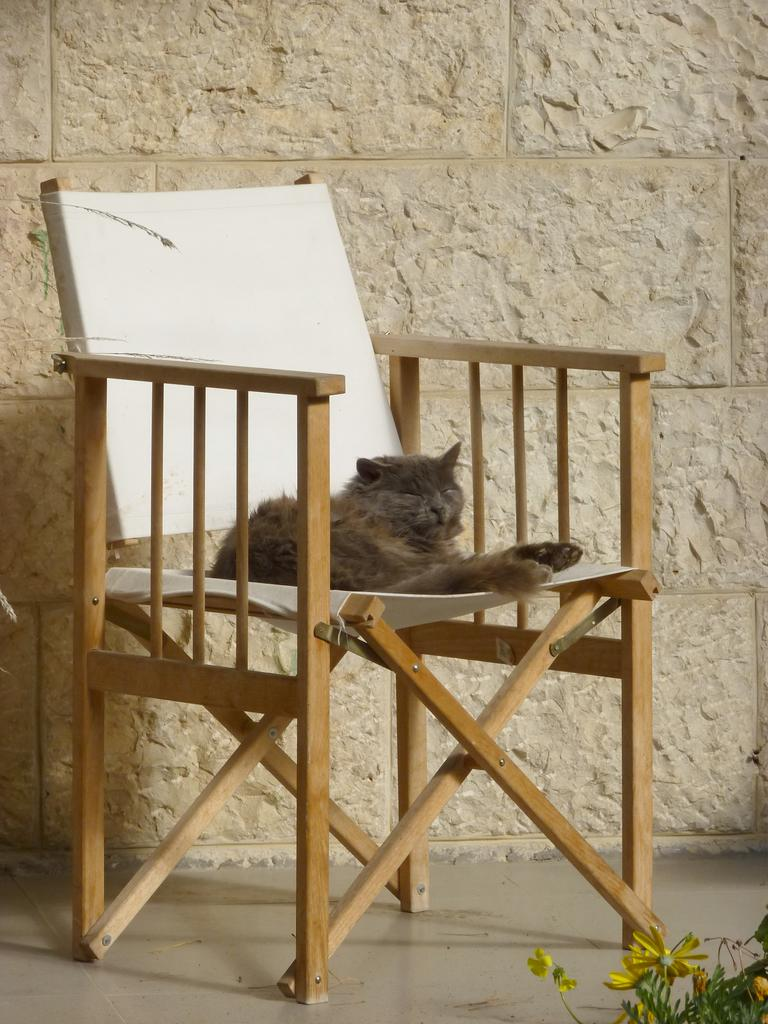What animal can be seen in the image? There is a cat in the image. Where is the cat sitting? The cat is sitting in a white color chair. What can be seen in the background of the image? There is a wall, a plant, and a flower in the background of the image. Can you see any volcanoes erupting in the image? No, there are no volcanoes present in the image. 